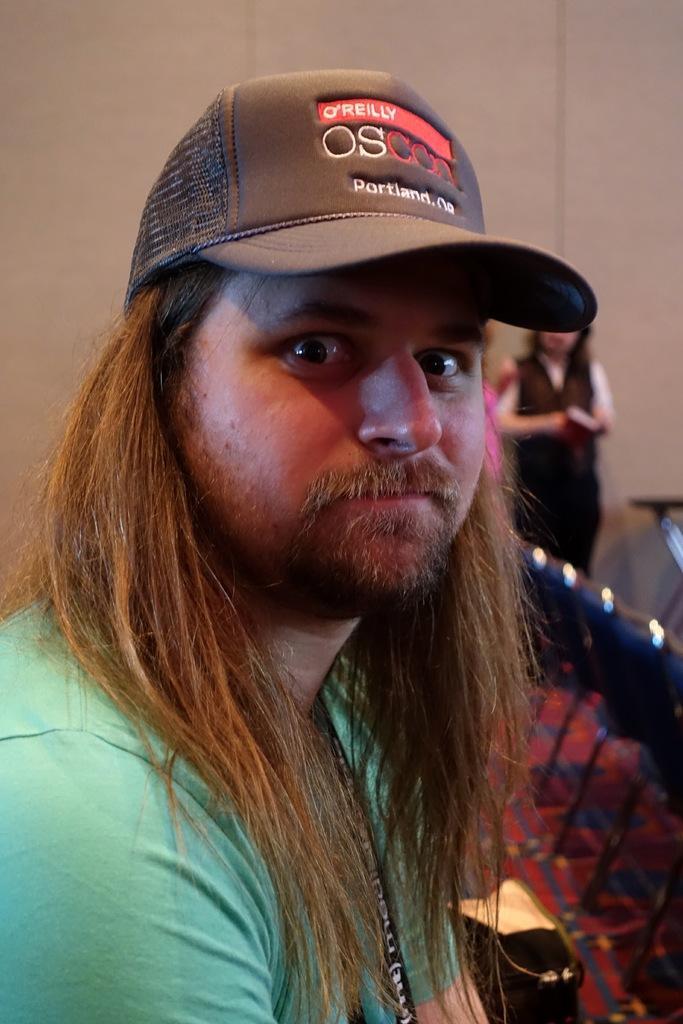Can you describe this image briefly? In this image, I can see the man sitting. He wore a cap. On the right side of the image, I think these are the chairs. In the background, I can see a person standing. This looks like the wall. 